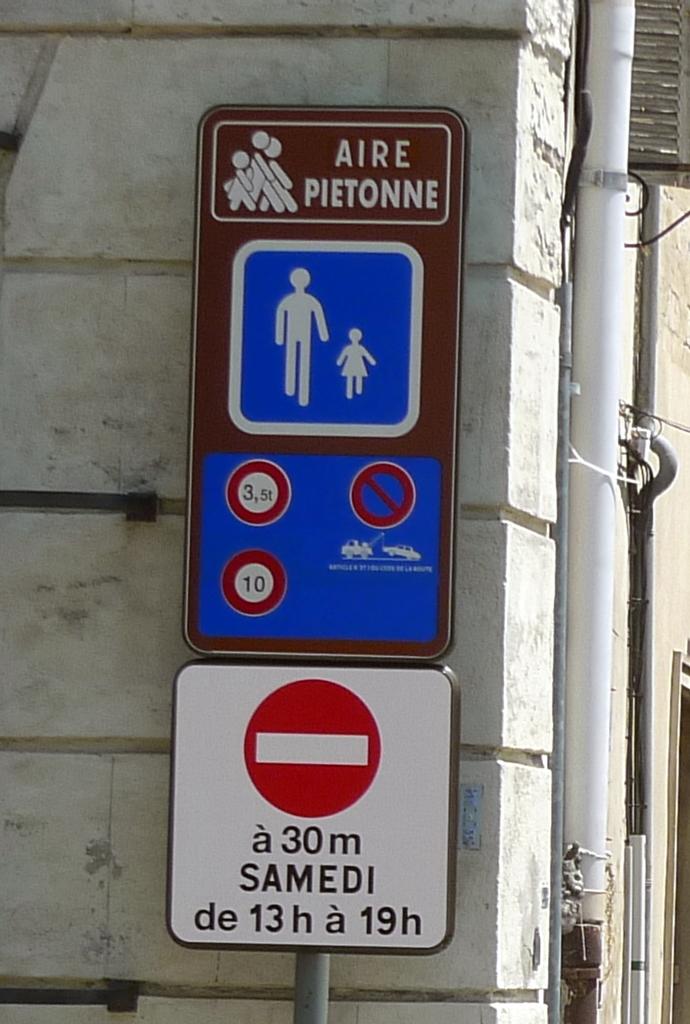What does the top of the sign say?
Your answer should be compact. Aire pietonne. What is the first sign?
Your response must be concise. Aire pietonne. 